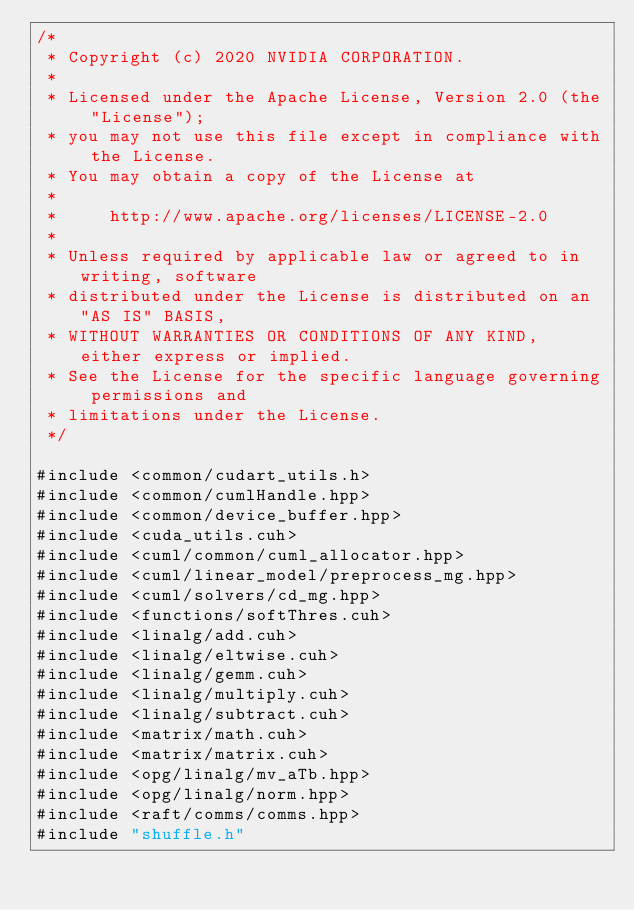Convert code to text. <code><loc_0><loc_0><loc_500><loc_500><_Cuda_>/*
 * Copyright (c) 2020 NVIDIA CORPORATION.
 *
 * Licensed under the Apache License, Version 2.0 (the "License");
 * you may not use this file except in compliance with the License.
 * You may obtain a copy of the License at
 *
 *     http://www.apache.org/licenses/LICENSE-2.0
 *
 * Unless required by applicable law or agreed to in writing, software
 * distributed under the License is distributed on an "AS IS" BASIS,
 * WITHOUT WARRANTIES OR CONDITIONS OF ANY KIND, either express or implied.
 * See the License for the specific language governing permissions and
 * limitations under the License.
 */

#include <common/cudart_utils.h>
#include <common/cumlHandle.hpp>
#include <common/device_buffer.hpp>
#include <cuda_utils.cuh>
#include <cuml/common/cuml_allocator.hpp>
#include <cuml/linear_model/preprocess_mg.hpp>
#include <cuml/solvers/cd_mg.hpp>
#include <functions/softThres.cuh>
#include <linalg/add.cuh>
#include <linalg/eltwise.cuh>
#include <linalg/gemm.cuh>
#include <linalg/multiply.cuh>
#include <linalg/subtract.cuh>
#include <matrix/math.cuh>
#include <matrix/matrix.cuh>
#include <opg/linalg/mv_aTb.hpp>
#include <opg/linalg/norm.hpp>
#include <raft/comms/comms.hpp>
#include "shuffle.h"
</code> 